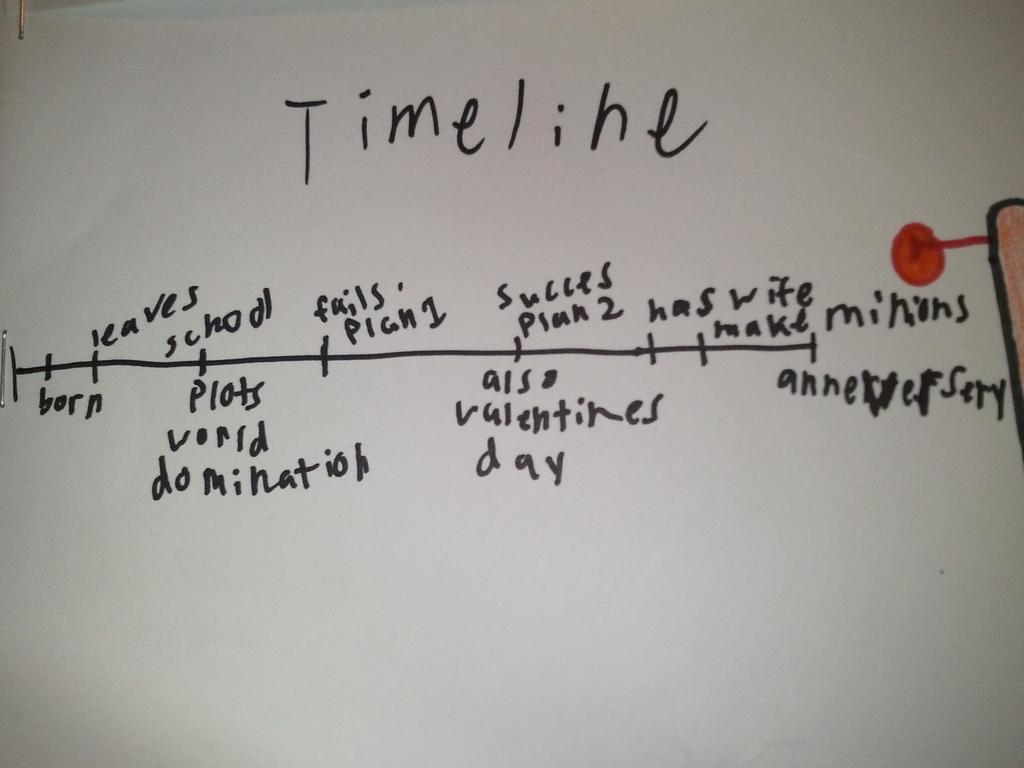<image>
Write a terse but informative summary of the picture. Timeline is written on a white board in black pen 